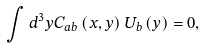<formula> <loc_0><loc_0><loc_500><loc_500>\int d ^ { 3 } y C _ { a b } \left ( x , y \right ) U _ { b } \left ( y \right ) = 0 ,</formula> 